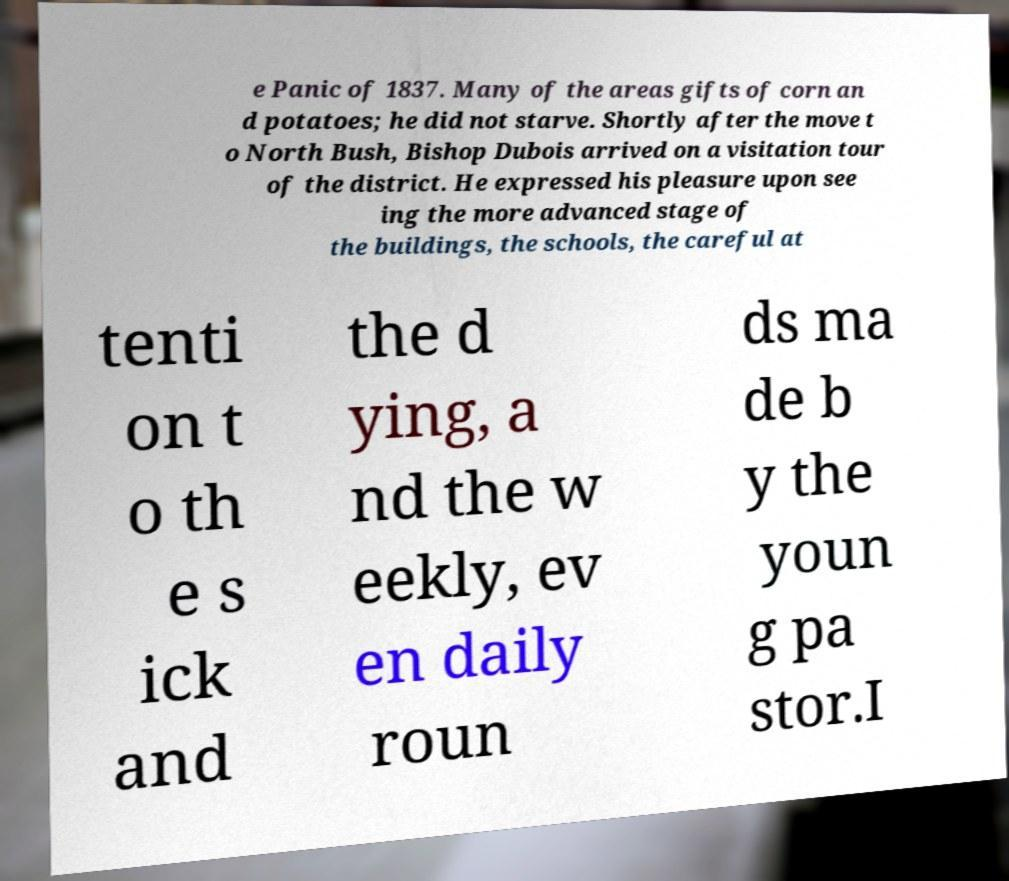Can you read and provide the text displayed in the image?This photo seems to have some interesting text. Can you extract and type it out for me? e Panic of 1837. Many of the areas gifts of corn an d potatoes; he did not starve. Shortly after the move t o North Bush, Bishop Dubois arrived on a visitation tour of the district. He expressed his pleasure upon see ing the more advanced stage of the buildings, the schools, the careful at tenti on t o th e s ick and the d ying, a nd the w eekly, ev en daily roun ds ma de b y the youn g pa stor.I 